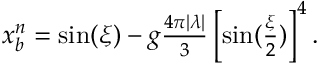Convert formula to latex. <formula><loc_0><loc_0><loc_500><loc_500>\begin{array} { r } { x _ { b } ^ { n } = \sin ( \xi ) - g \frac { 4 \pi | \lambda | } { 3 } \left [ \sin ( \frac { \xi } { 2 } ) \right ] ^ { 4 } . } \end{array}</formula> 